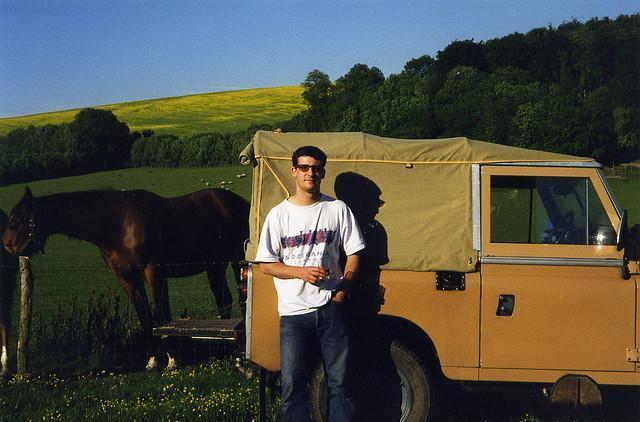Verify the accuracy of this image caption: "The horse is at the back of the truck.".
Answer yes or no. Yes. 